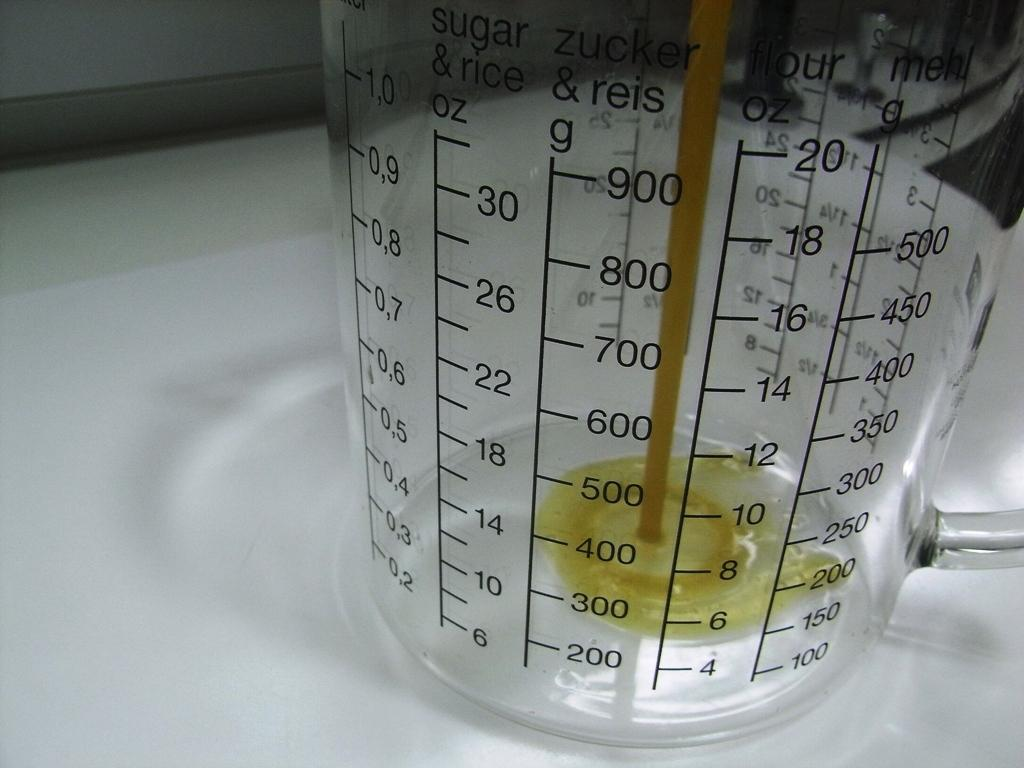<image>
Summarize the visual content of the image. measuring cup for sugar, rice, flour, and zucker 